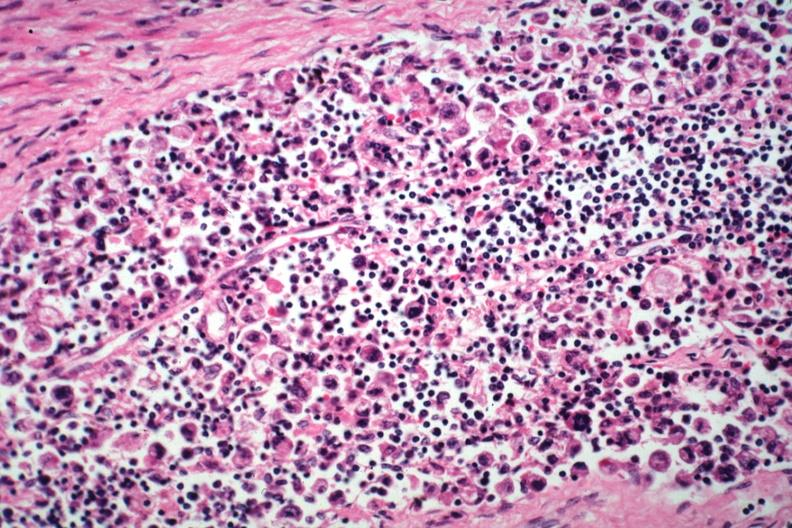what is present?
Answer the question using a single word or phrase. Lymph node 